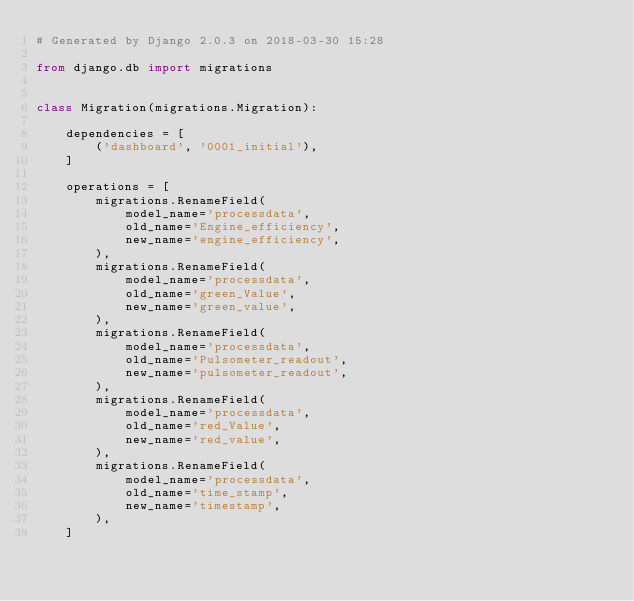<code> <loc_0><loc_0><loc_500><loc_500><_Python_># Generated by Django 2.0.3 on 2018-03-30 15:28

from django.db import migrations


class Migration(migrations.Migration):

    dependencies = [
        ('dashboard', '0001_initial'),
    ]

    operations = [
        migrations.RenameField(
            model_name='processdata',
            old_name='Engine_efficiency',
            new_name='engine_efficiency',
        ),
        migrations.RenameField(
            model_name='processdata',
            old_name='green_Value',
            new_name='green_value',
        ),
        migrations.RenameField(
            model_name='processdata',
            old_name='Pulsometer_readout',
            new_name='pulsometer_readout',
        ),
        migrations.RenameField(
            model_name='processdata',
            old_name='red_Value',
            new_name='red_value',
        ),
        migrations.RenameField(
            model_name='processdata',
            old_name='time_stamp',
            new_name='timestamp',
        ),
    ]
</code> 